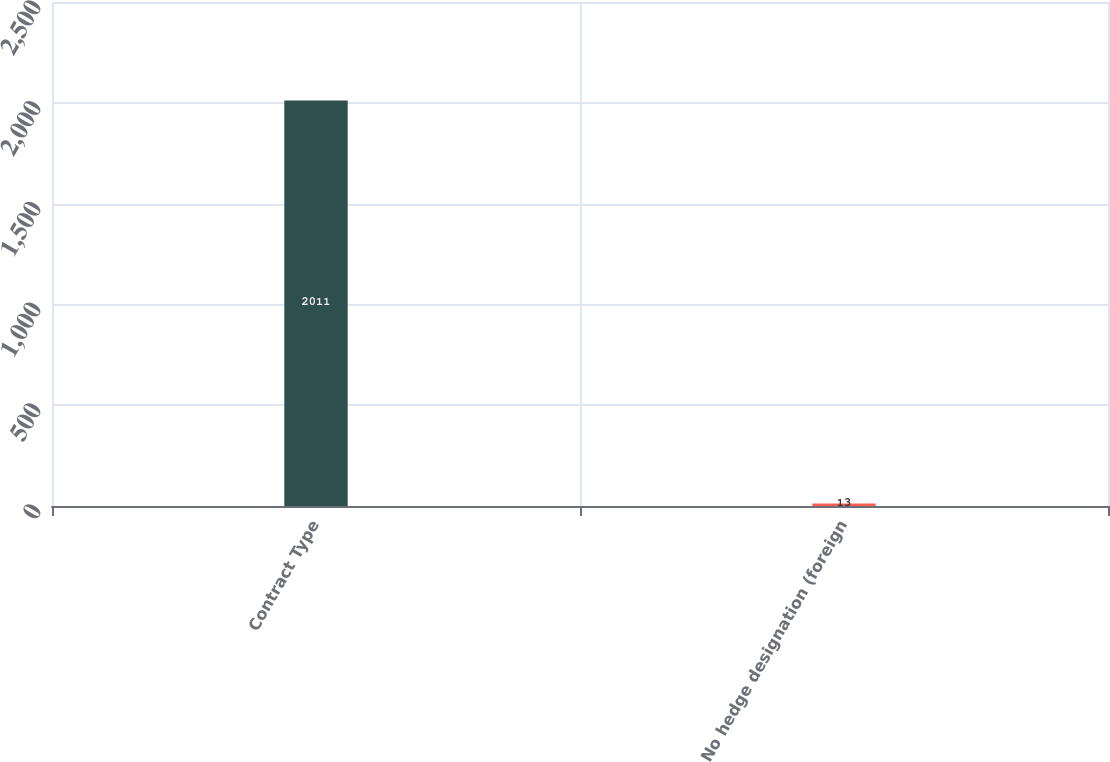<chart> <loc_0><loc_0><loc_500><loc_500><bar_chart><fcel>Contract Type<fcel>No hedge designation (foreign<nl><fcel>2011<fcel>13<nl></chart> 